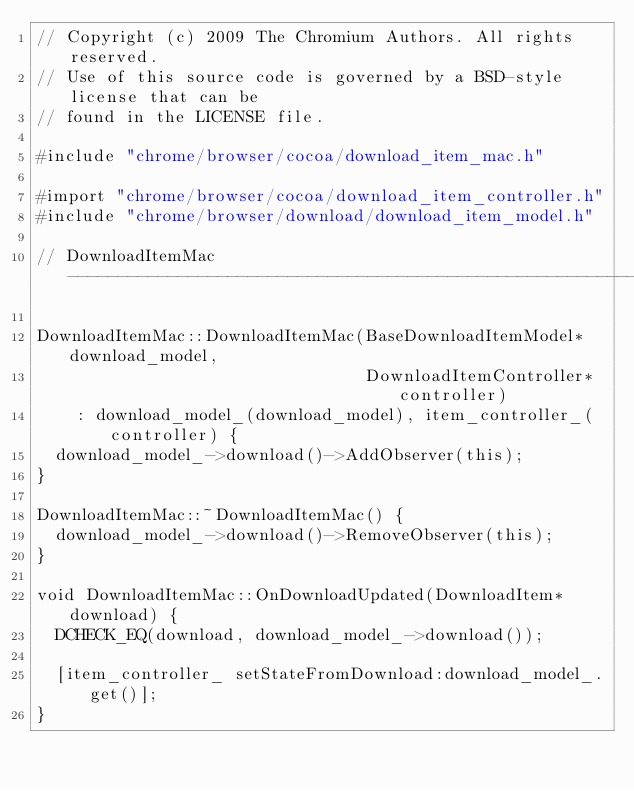Convert code to text. <code><loc_0><loc_0><loc_500><loc_500><_ObjectiveC_>// Copyright (c) 2009 The Chromium Authors. All rights reserved.
// Use of this source code is governed by a BSD-style license that can be
// found in the LICENSE file.

#include "chrome/browser/cocoa/download_item_mac.h"

#import "chrome/browser/cocoa/download_item_controller.h"
#include "chrome/browser/download/download_item_model.h"

// DownloadItemMac -------------------------------------------------------------

DownloadItemMac::DownloadItemMac(BaseDownloadItemModel* download_model,
                                 DownloadItemController* controller)
    : download_model_(download_model), item_controller_(controller) {
  download_model_->download()->AddObserver(this);
}

DownloadItemMac::~DownloadItemMac() {
  download_model_->download()->RemoveObserver(this);
}

void DownloadItemMac::OnDownloadUpdated(DownloadItem* download) {
  DCHECK_EQ(download, download_model_->download());

  [item_controller_ setStateFromDownload:download_model_.get()];
}
</code> 